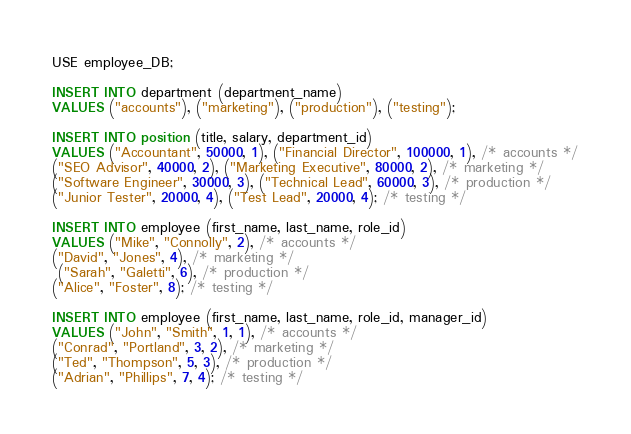<code> <loc_0><loc_0><loc_500><loc_500><_SQL_>USE employee_DB;

INSERT INTO department (department_name)
VALUES ("accounts"), ("marketing"), ("production"), ("testing");

INSERT INTO position (title, salary, department_id)
VALUES ("Accountant", 50000, 1), ("Financial Director", 100000, 1), /* accounts */
("SEO Advisor", 40000, 2), ("Marketing Executive", 80000, 2), /* marketing */
("Software Engineer", 30000, 3), ("Technical Lead", 60000, 3), /* production */
("Junior Tester", 20000, 4), ("Test Lead", 20000, 4); /* testing */

INSERT INTO employee (first_name, last_name, role_id)
VALUES ("Mike", "Connolly", 2), /* accounts */
("David", "Jones", 4), /* marketing */
 ("Sarah", "Galetti", 6), /* production */
("Alice", "Foster", 8); /* testing */

INSERT INTO employee (first_name, last_name, role_id, manager_id)
VALUES ("John", "Smith", 1, 1), /* accounts */
("Conrad", "Portland", 3, 2), /* marketing */
("Ted", "Thompson", 5, 3), /* production */
("Adrian", "Phillips", 7, 4); /* testing */</code> 